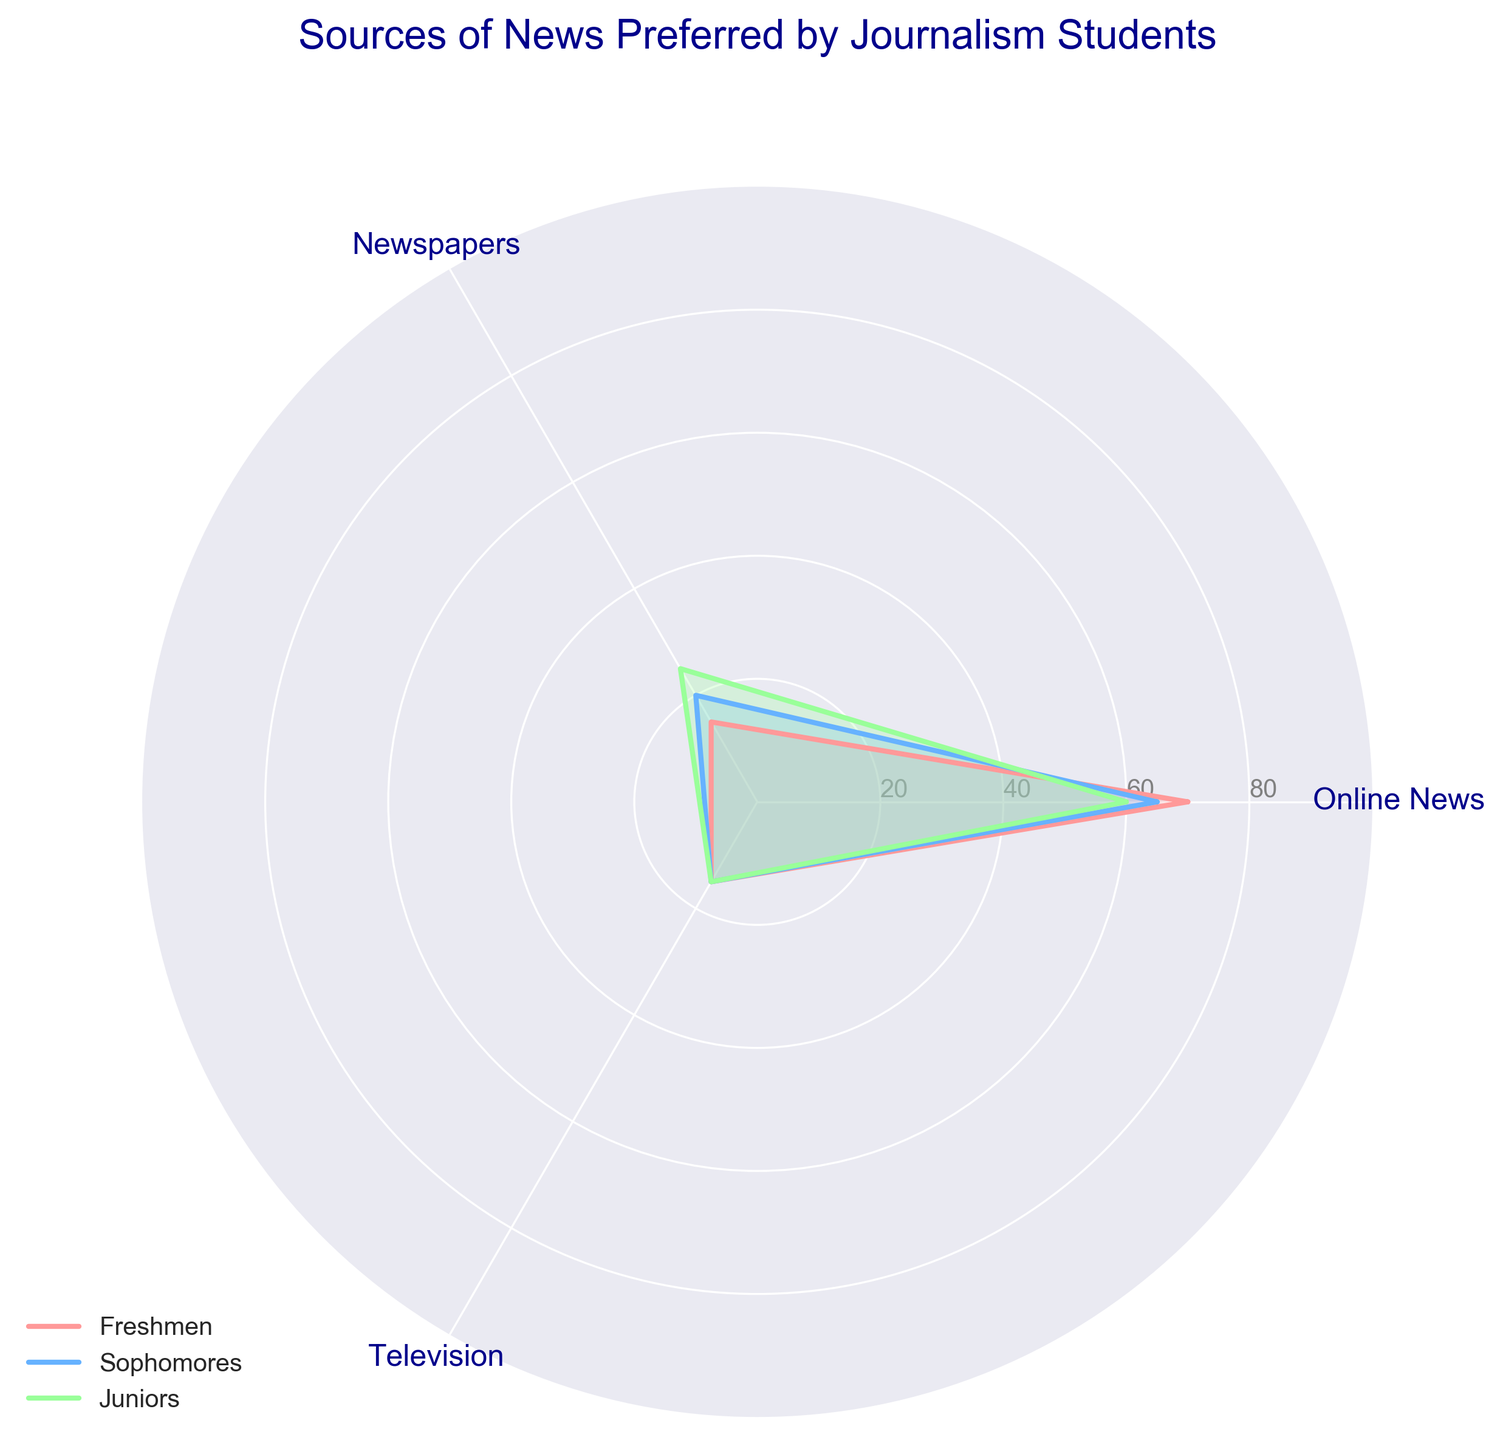What is the title of the figure? The title of the figure is displayed at the top and it is "Sources of News Preferred by Journalism Students".
Answer: Sources of News Preferred by Journalism Students What are the three sources of news represented in the radar chart? The three sources of news are the categories labeled on the chart at each vertex, which are Online News, Newspapers, and Television.
Answer: Online News, Newspapers, Television Which source of news do Freshmen prefer the most? By looking at the vertices labeled with Freshmen values, the segment corresponding to Online News extends the farthest, indicating Freshmen prefer Online News the most.
Answer: Online News What is the percentage of Sophomores that prefer Newspapers? Look at the vertex labeled Newspapers and find the value for the Sophomores line, which is 20.
Answer: 20 How do the preferences for Online News change from Freshmen to Seniors? Compare the values of Online News for Freshmen (70), Sophomores (65), Juniors (60), and notice a decreasing trend for each subsequent year (Seniors' data is not plotted but inferred that it continues from the trend and table).
Answer: Decreases consistently How does the preference for Newspapers change from Freshmen to Juniors? Examine the values for Newspapers for Freshmen (15), Sophomores (20), and Juniors (25). These values show a steady increase.
Answer: Increases consistently Do any of the groups have a differing preference for Television? For all groups (Freshmen, Sophomores, Juniors) plotted, the preference for Television shows as the same value of 15, implying no differences among groups.
Answer: No What’s the overall trend for preference in Newspapers from Freshmen to Juniors? Compare the data points: Freshmen (15), Sophomores (20), and Juniors (25) for Newspapers. The values are increasing as the students progress through school years.
Answer: Increasing trend What is the average preference for Online News among Freshmen, Sophomores, and Juniors? Sum the percentages of each group for Online News (70 + 65 + 60) and divide by the number of groups (3). So, (70 + 65 + 60) / 3 = 195 / 3.
Answer: 65 Which group shows the highest difference between preferences for Online News and Newspapers? Calculate the difference for each group: Freshmen (70 - 15 = 55), Sophomores (65 - 20 = 45), Juniors (60 - 25 = 35). Freshmen show the highest difference of 55.
Answer: Freshmen 